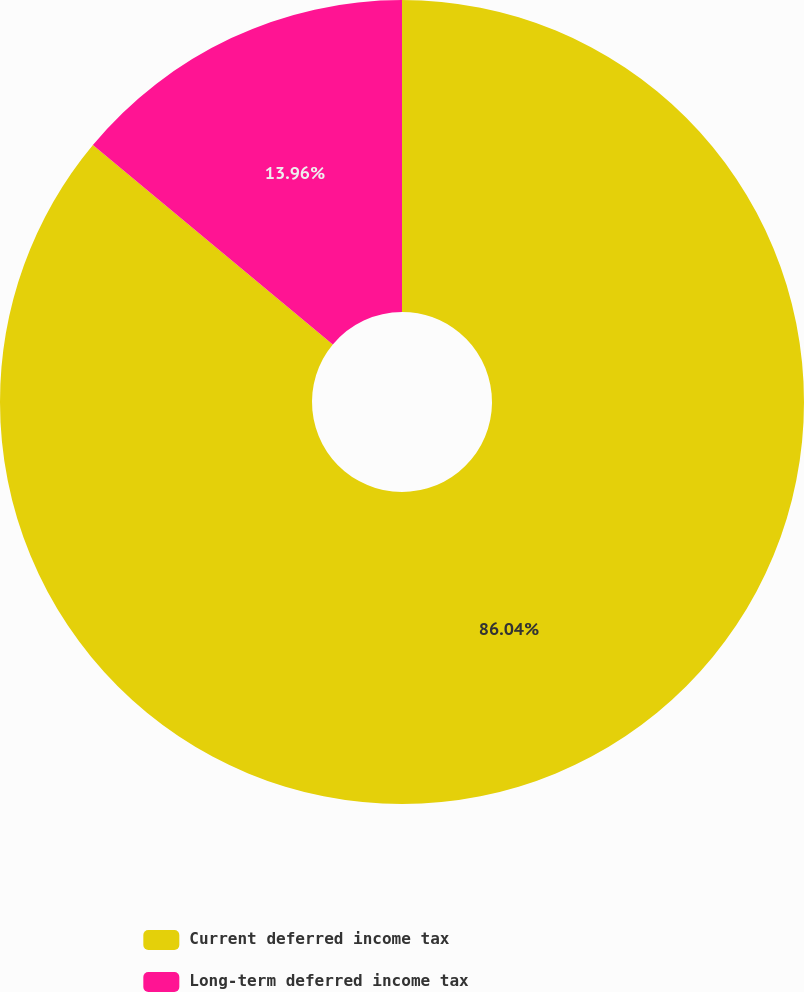Convert chart to OTSL. <chart><loc_0><loc_0><loc_500><loc_500><pie_chart><fcel>Current deferred income tax<fcel>Long-term deferred income tax<nl><fcel>86.04%<fcel>13.96%<nl></chart> 